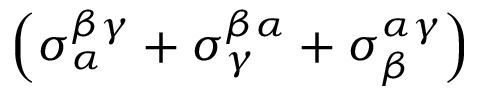Convert formula to latex. <formula><loc_0><loc_0><loc_500><loc_500>\left ( \sigma _ { \alpha } ^ { \beta \gamma } + \sigma _ { \gamma } ^ { \beta \alpha } + \sigma _ { \beta } ^ { \alpha \gamma } \right )</formula> 